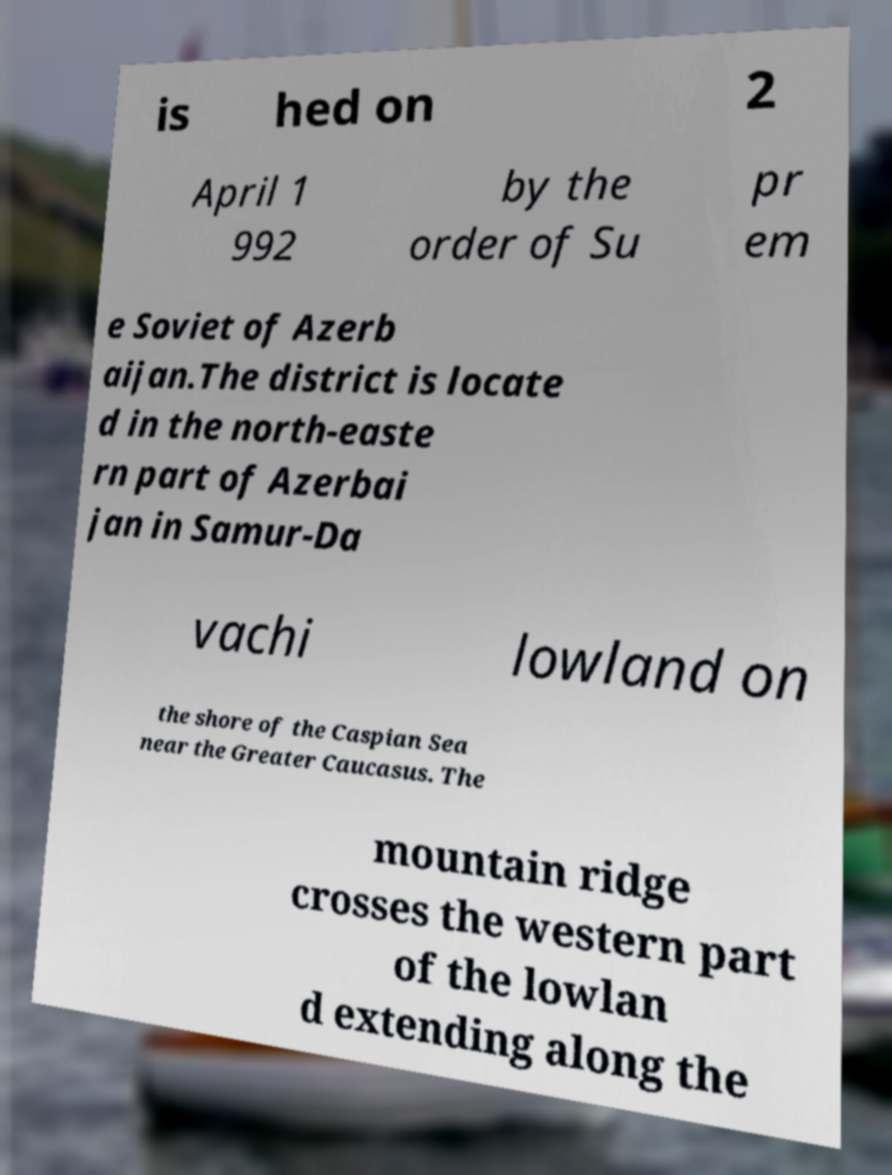Could you assist in decoding the text presented in this image and type it out clearly? is hed on 2 April 1 992 by the order of Su pr em e Soviet of Azerb aijan.The district is locate d in the north-easte rn part of Azerbai jan in Samur-Da vachi lowland on the shore of the Caspian Sea near the Greater Caucasus. The mountain ridge crosses the western part of the lowlan d extending along the 